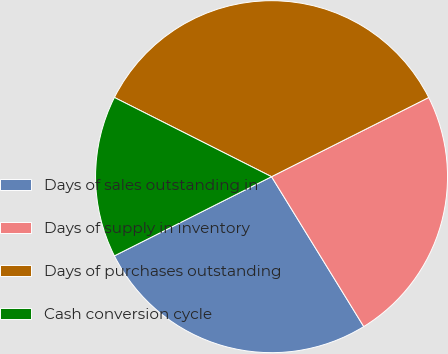Convert chart. <chart><loc_0><loc_0><loc_500><loc_500><pie_chart><fcel>Days of sales outstanding in<fcel>Days of supply in inventory<fcel>Days of purchases outstanding<fcel>Cash conversion cycle<nl><fcel>26.35%<fcel>23.65%<fcel>35.14%<fcel>14.86%<nl></chart> 